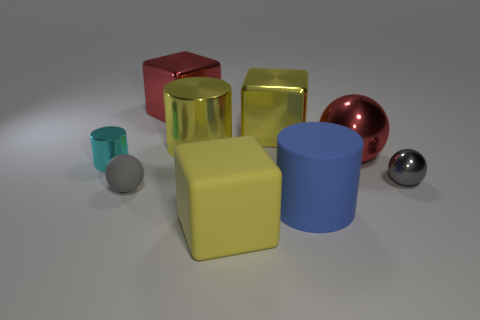Subtract all shiny balls. How many balls are left? 1 Subtract all gray spheres. How many spheres are left? 1 Subtract all cyan cylinders. How many gray balls are left? 2 Add 6 gray metal balls. How many gray metal balls exist? 7 Subtract 0 cyan spheres. How many objects are left? 9 Subtract all balls. How many objects are left? 6 Subtract 2 cylinders. How many cylinders are left? 1 Subtract all purple balls. Subtract all red blocks. How many balls are left? 3 Subtract all large cyan rubber things. Subtract all tiny spheres. How many objects are left? 7 Add 7 red blocks. How many red blocks are left? 8 